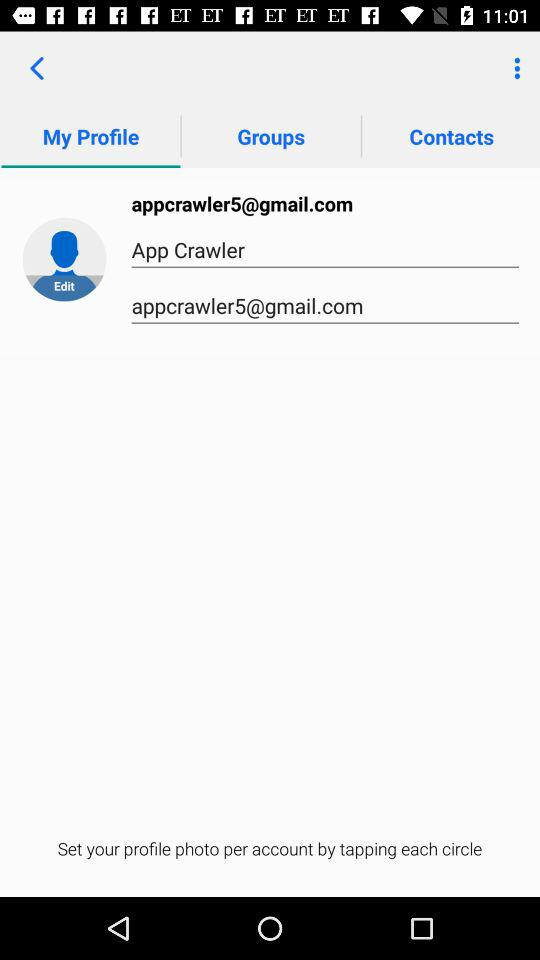What is the email address? The email address is appcrawler5@gmail.com. 